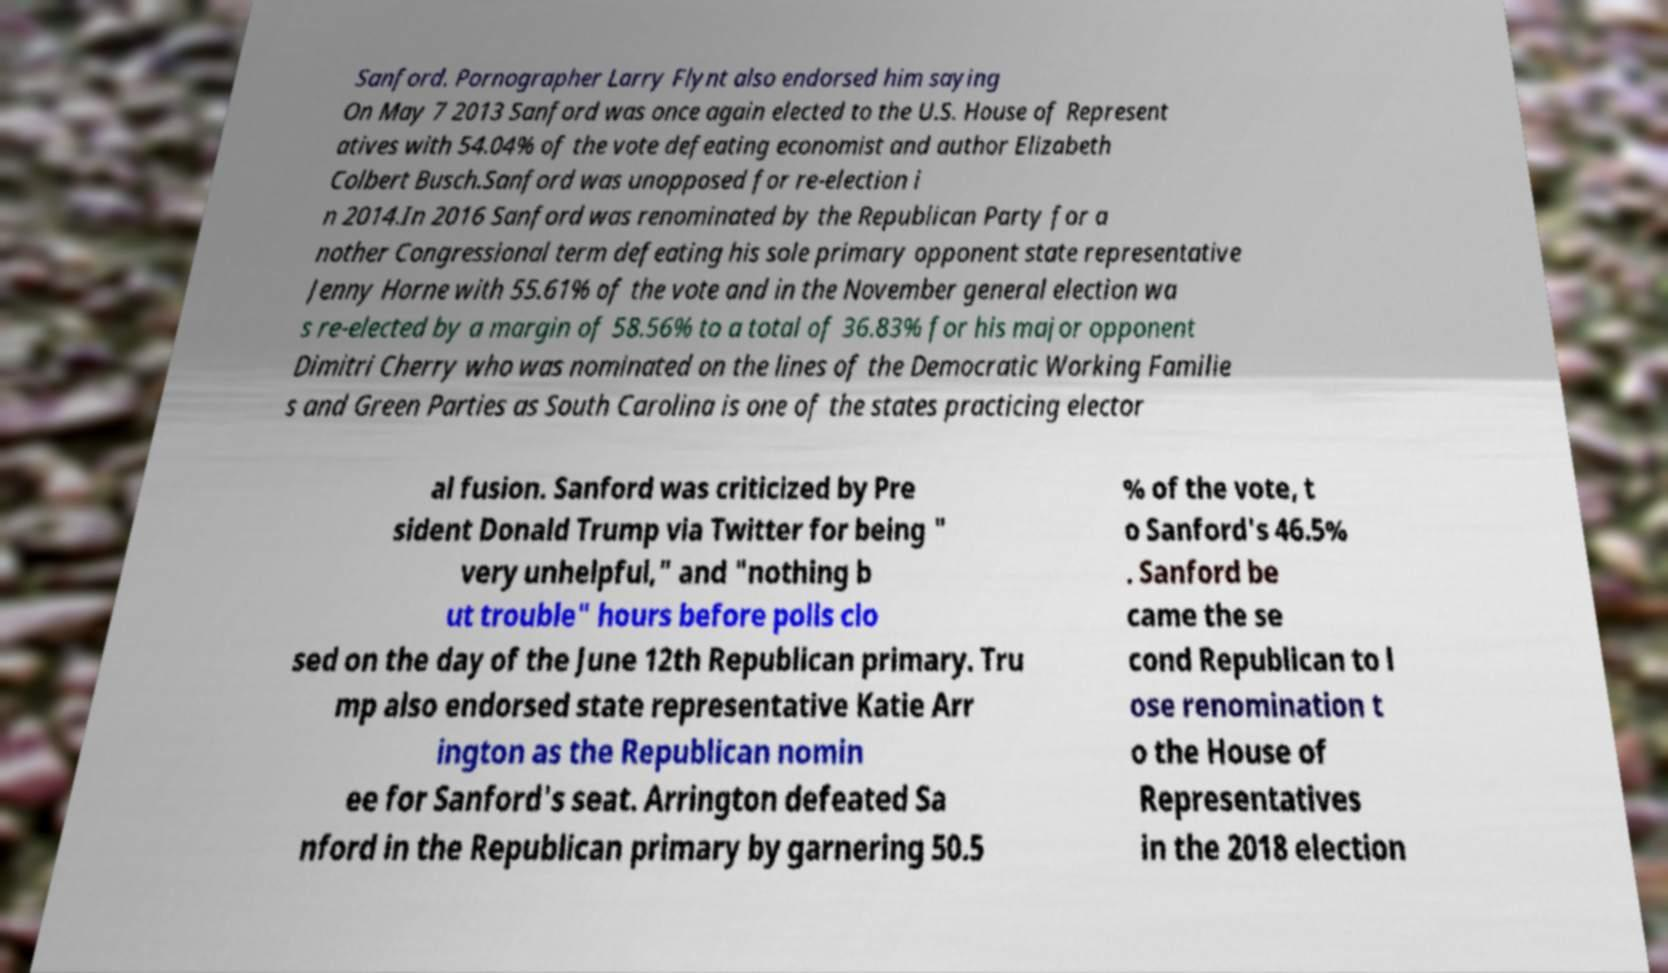Can you read and provide the text displayed in the image?This photo seems to have some interesting text. Can you extract and type it out for me? Sanford. Pornographer Larry Flynt also endorsed him saying On May 7 2013 Sanford was once again elected to the U.S. House of Represent atives with 54.04% of the vote defeating economist and author Elizabeth Colbert Busch.Sanford was unopposed for re-election i n 2014.In 2016 Sanford was renominated by the Republican Party for a nother Congressional term defeating his sole primary opponent state representative Jenny Horne with 55.61% of the vote and in the November general election wa s re-elected by a margin of 58.56% to a total of 36.83% for his major opponent Dimitri Cherry who was nominated on the lines of the Democratic Working Familie s and Green Parties as South Carolina is one of the states practicing elector al fusion. Sanford was criticized by Pre sident Donald Trump via Twitter for being " very unhelpful," and "nothing b ut trouble" hours before polls clo sed on the day of the June 12th Republican primary. Tru mp also endorsed state representative Katie Arr ington as the Republican nomin ee for Sanford's seat. Arrington defeated Sa nford in the Republican primary by garnering 50.5 % of the vote, t o Sanford's 46.5% . Sanford be came the se cond Republican to l ose renomination t o the House of Representatives in the 2018 election 